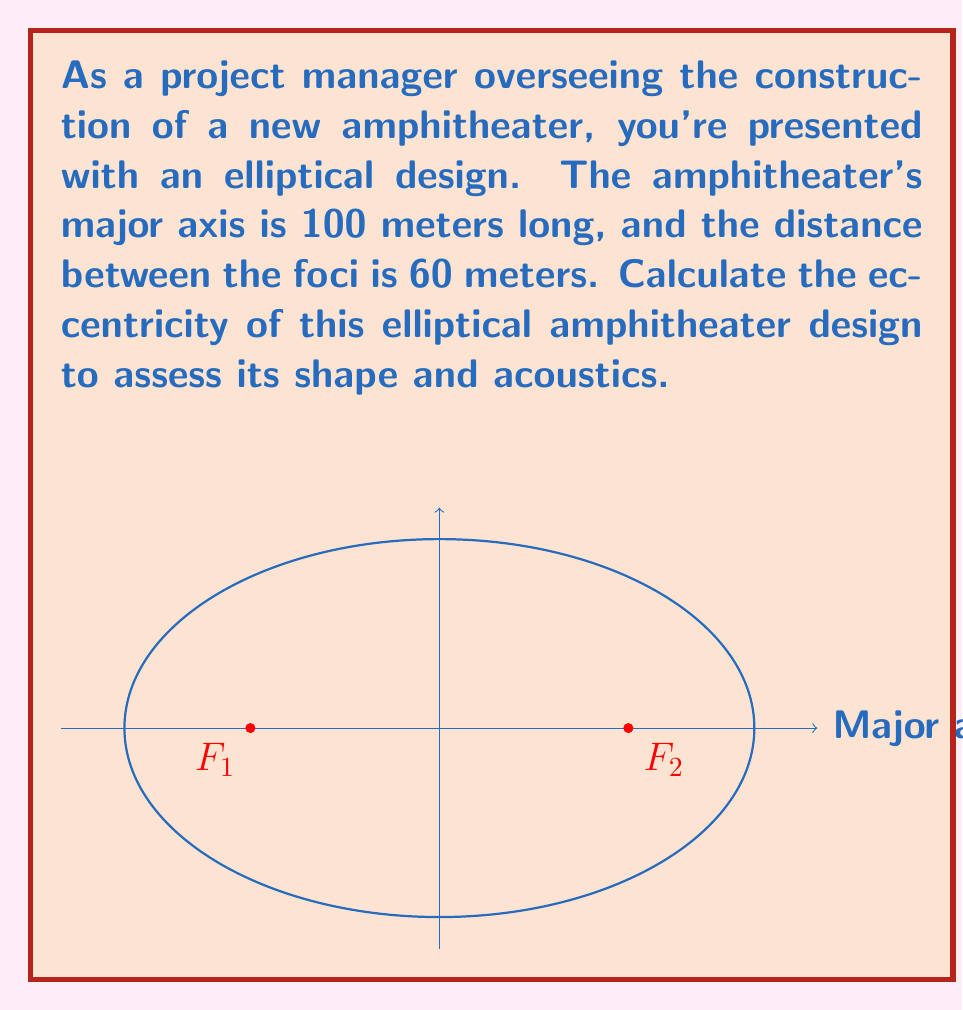Solve this math problem. Let's approach this step-by-step:

1) The eccentricity ($e$) of an ellipse is defined as the ratio of the distance between the foci to the length of the major axis. It can be calculated using the formula:

   $$e = \frac{c}{a}$$

   where $c$ is half the distance between the foci, and $a$ is half the length of the major axis.

2) From the given information:
   - Major axis length = 100 meters
   - Distance between foci = 60 meters

3) Calculate $a$:
   $$a = \frac{100}{2} = 50\text{ meters}$$

4) Calculate $c$:
   $$c = \frac{60}{2} = 30\text{ meters}$$

5) Now, we can substitute these values into the eccentricity formula:

   $$e = \frac{c}{a} = \frac{30}{50} = \frac{3}{5} = 0.6$$

6) Therefore, the eccentricity of the elliptical amphitheater is 0.6.

This value (between 0 and 1) indicates that the ellipse is moderately elongated, which could affect the acoustics and viewing angles in the amphitheater design.
Answer: $0.6$ 